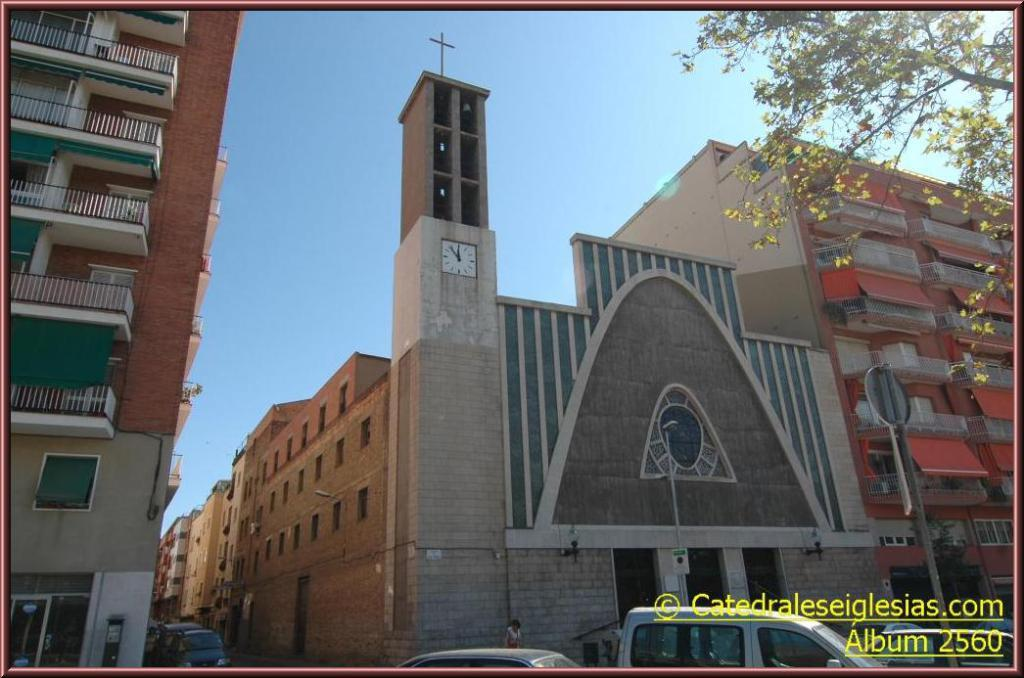What type of structures can be seen in the image? There are buildings in the image. What is in front of the buildings? There are cars in front of the buildings. Can you describe any specific features of the buildings? A clock is attached to one of the buildings. What else is visible in front of the building? There is a tree in front of the building. What can be seen in the sky in the image? The sky is visible in the image. How many books are stacked in the cellar of the building in the image? There is no mention of books or a cellar in the image, so we cannot determine the number of books stacked in the cellar. 